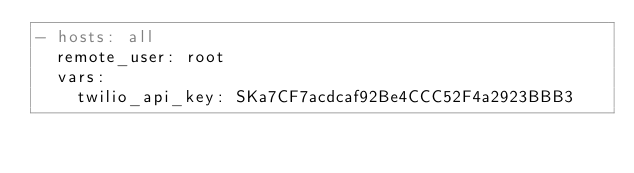<code> <loc_0><loc_0><loc_500><loc_500><_YAML_>- hosts: all
  remote_user: root
  vars:
    twilio_api_key: SKa7CF7acdcaf92Be4CCC52F4a2923BBB3

</code> 